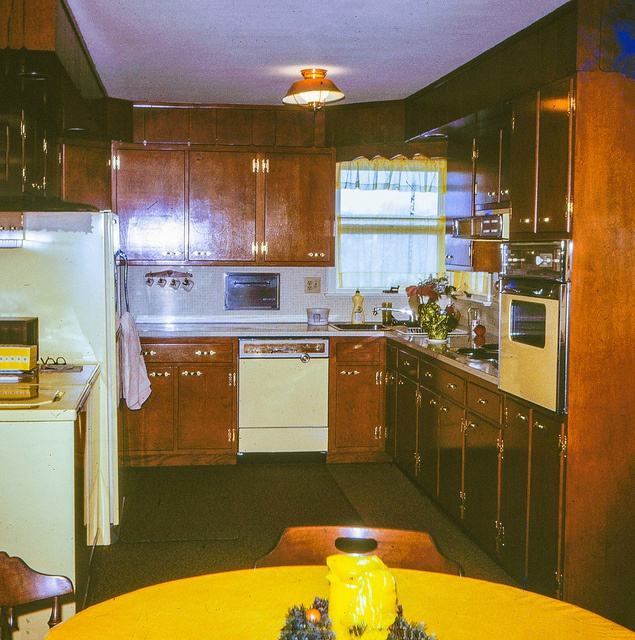Describe the objects in this image and their specific colors. I can see dining table in black, orange, gold, and olive tones, refrigerator in black, lightgray, beige, darkgray, and lightblue tones, oven in black, tan, olive, and gray tones, chair in black, brown, olive, and orange tones, and vase in black, gold, ivory, and khaki tones in this image. 